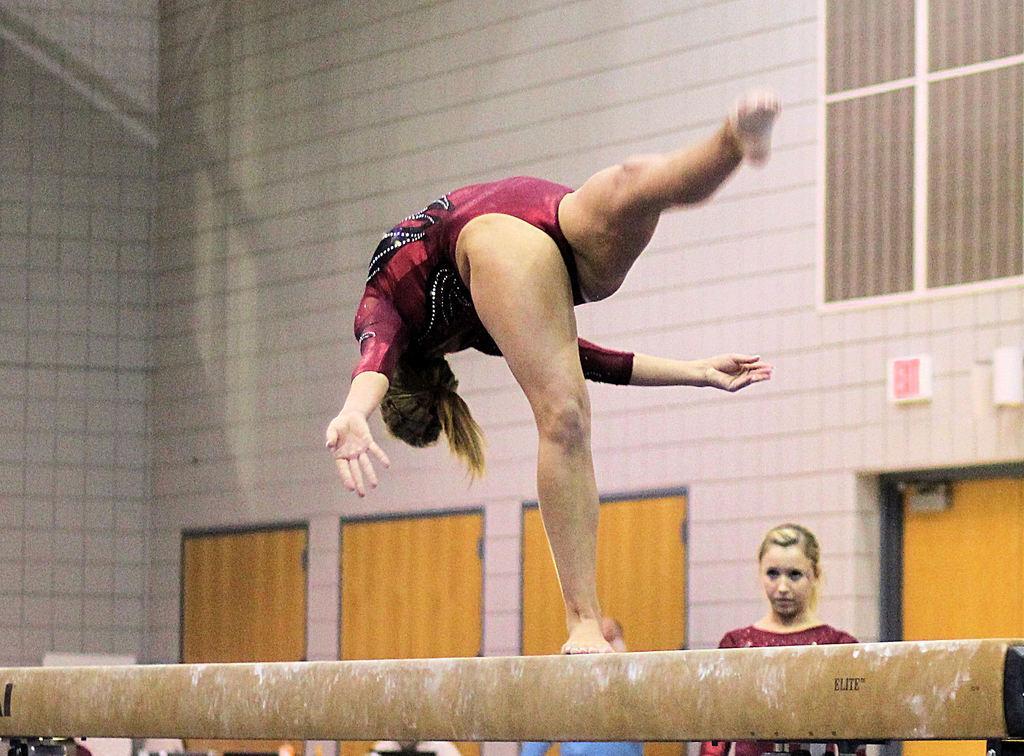Could you give a brief overview of what you see in this image? This picture shows the inner view of a building. There is one window, some objects attached to the wall, one girl standing, some chairs, one man with blue shirt standing, some doors, one balance beam, some objects are on the surface and one woman doing gymnastics on the balance beam. 